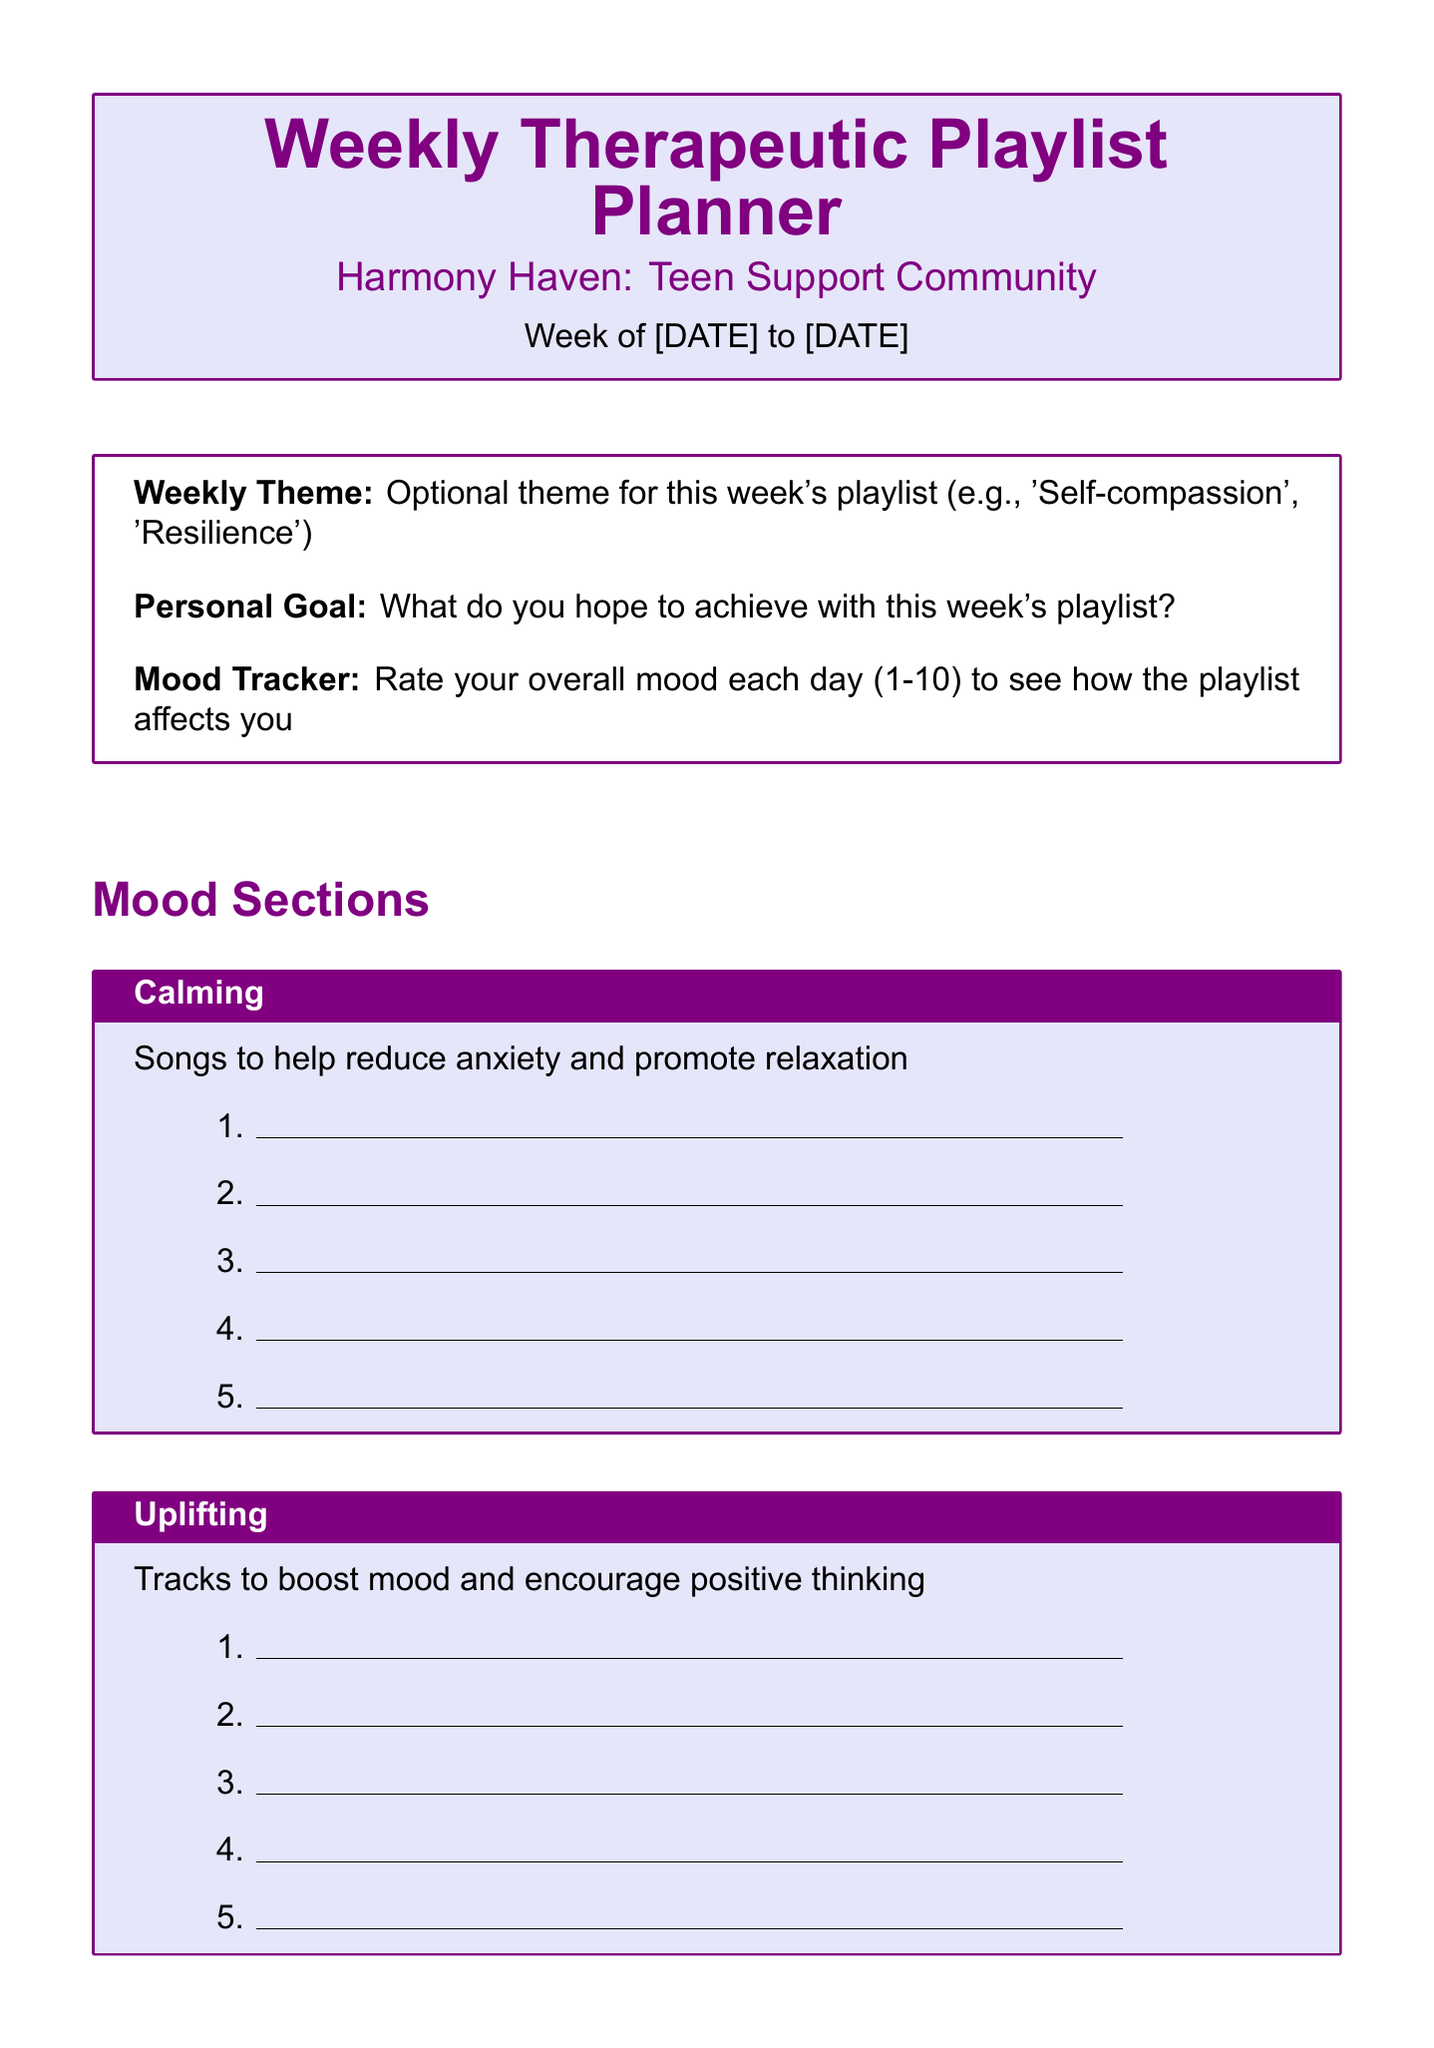What is the title of the form? The title of the form is clearly mentioned in the document.
Answer: Weekly Therapeutic Playlist Planner What community is this form associated with? The document specifies the name of the community in the introduction section.
Answer: Harmony Haven: Teen Support Community How many song slots are provided for the uplifting mood section? The document lists the number of song slots for each mood section.
Answer: 5 What is an optional theme for this week's playlist? The document indicates that users can provide a theme, giving examples in the description.
Answer: Self-compassion Which resource can you call for suicide prevention? The document includes a list of helpful resources with contact details.
Answer: 1-800-273-8255 What do you hope to achieve with this week's playlist? This is a personal goal described in the additional fields of the form.
Answer: Personal Goal How many mood sections are described in the document? The document lists the various mood sections in the mood categories.
Answer: 5 What is the purpose of the disclaimer? The disclaimer explains the intent and limitations of the playlist and directs readers to professionals.
Answer: Supportive tool How can participants share their playlists? The sharing prompt encourages sharing during the group's virtual meetups.
Answer: Weekly virtual meetups 